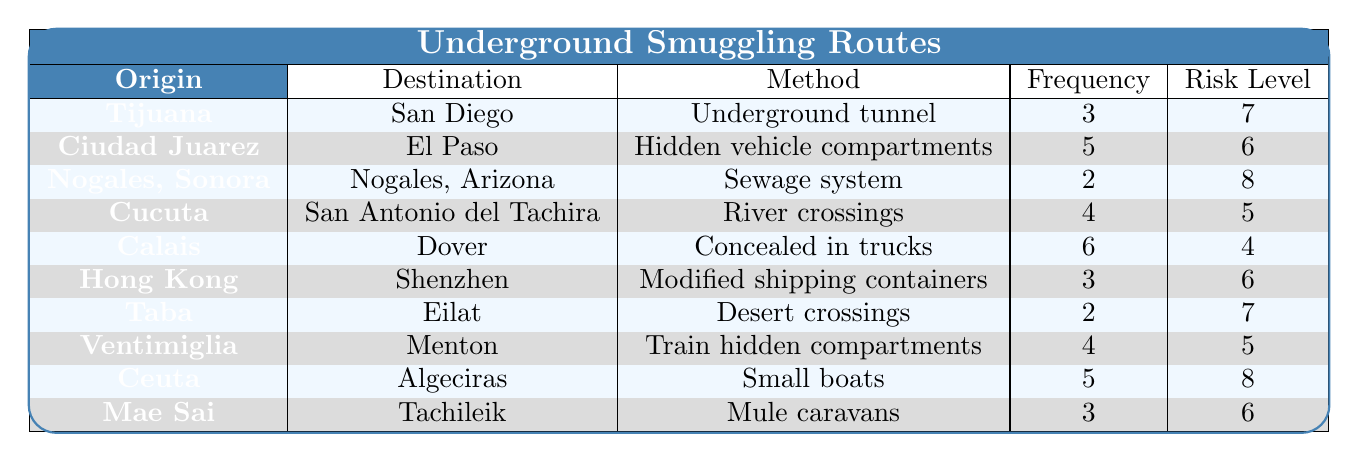What smuggling method has the highest frequency? By reviewing the "Frequency" column in the table, "Concealed in trucks" has the highest frequency of 6.
Answer: Concealed in trucks Which route has the lowest risk level? The "Risk Level" column shows that "Concealed in trucks" has a risk level of 4, which is the lowest.
Answer: 4 How many routes have a risk level of 6? The routes that have a risk level of 6 are: Ciudad Juarez to El Paso, Hong Kong to Shenzhen, and Mae Sai to Tachileik; there are 3 such routes total.
Answer: 3 What is the total frequency of routes that use "river crossings" as a method? There is one route using "river crossings," which has a frequency of 4. Thus, the total frequency is 4.
Answer: 4 Are there more routes originating from Mexico than from other countries? The routes from Mexico include Tijuana, Ciudad Juarez, Nogales, and Cucuta, totaling 4 routes; there are 6 from other countries, thus there are more from the latter.
Answer: No Which origin-destination pair has the highest risk level and what is that level? The pair "Nogales, Sonora to Nogales, Arizona" has the highest risk level of 8.
Answer: 8 What is the average frequency of routes that use "mule caravans" or "hidden vehicle compartments"? The frequency for "mule caravans" is 3 and for "hidden vehicle compartments" is 5. Summing these (3 + 5 = 8) and dividing by 2 gives an average of 4.
Answer: 4 How many routes use a method that involves vehicles? The methods involving vehicles are "hidden vehicle compartments" and "concealed in trucks," amounting to 2 routes total.
Answer: 2 Is there any route with a frequency of 2, and if so, what are the origins and destinations? Yes, the routes with a frequency of 2 are "Nogales, Sonora to Nogales, Arizona" and "Taba to Eilat."
Answer: Yes, Nogales, Sonora to Nogales, Arizona and Taba to Eilat What percentage of the routes have a risk level of 7 or higher? The routes with a risk level of 7 or higher are "Tijuana to San Diego", "Nogales, Sonora to Nogales, Arizona", "Taba to Eilat", and "Ceuta to Algeciras," totaling 4 routes. The total number of routes is 10, so the percentage is (4/10) * 100 = 40%.
Answer: 40% 